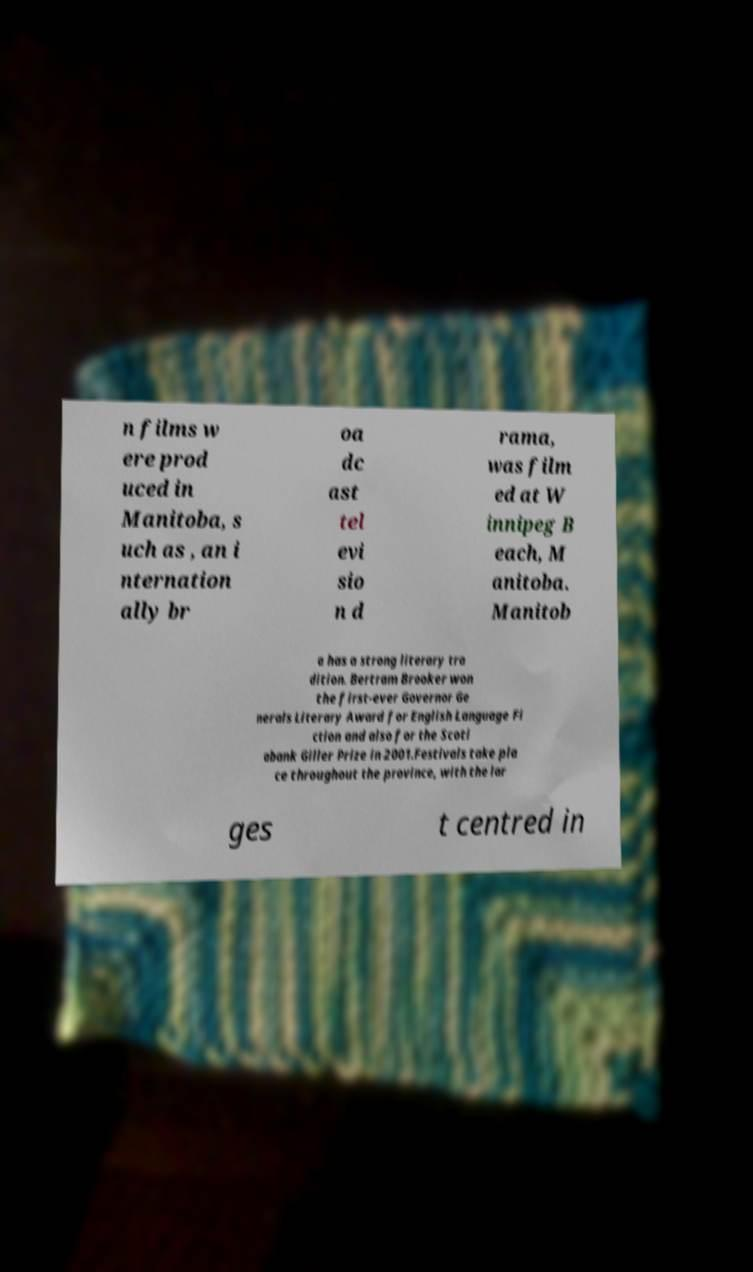What messages or text are displayed in this image? I need them in a readable, typed format. n films w ere prod uced in Manitoba, s uch as , an i nternation ally br oa dc ast tel evi sio n d rama, was film ed at W innipeg B each, M anitoba. Manitob a has a strong literary tra dition. Bertram Brooker won the first-ever Governor Ge nerals Literary Award for English Language Fi ction and also for the Scoti abank Giller Prize in 2001.Festivals take pla ce throughout the province, with the lar ges t centred in 